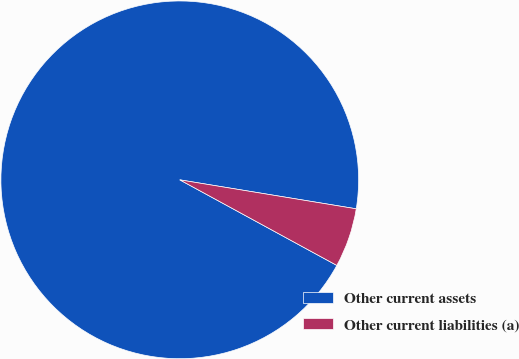Convert chart to OTSL. <chart><loc_0><loc_0><loc_500><loc_500><pie_chart><fcel>Other current assets<fcel>Other current liabilities (a)<nl><fcel>94.65%<fcel>5.35%<nl></chart> 